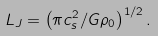<formula> <loc_0><loc_0><loc_500><loc_500>L _ { J } = \left ( { \pi c _ { s } ^ { 2 } / G \rho _ { 0 } } \right ) ^ { 1 / 2 } .</formula> 